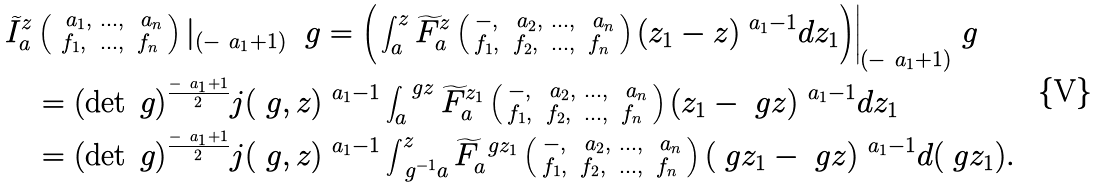Convert formula to latex. <formula><loc_0><loc_0><loc_500><loc_500>\widetilde { I } ^ { z } _ { a } & \left ( \begin{smallmatrix} \ a _ { 1 } , & \dots , & \ a _ { n } \\ f _ { 1 } , & \dots , & f _ { n } \end{smallmatrix} \right ) | _ { ( - \ a _ { 1 } + 1 ) } \ \ g = \Big ( \int _ { a } ^ { z } \widetilde { F } ^ { z } _ { a } \left ( \begin{smallmatrix} - , & \ a _ { 2 } , & \dots , & \ a _ { n } \\ f _ { 1 } , & f _ { 2 } , & \dots , & f _ { n } \end{smallmatrix} \right ) ( z _ { 1 } - z ) ^ { \ a _ { 1 } - 1 } d z _ { 1 } \Big ) \Big | _ { ( - \ a _ { 1 } + 1 ) } \ g \\ & = ( \det \ g ) ^ { \frac { - \ a _ { 1 } + 1 } { 2 } } j ( \ g , z ) ^ { \ a _ { 1 } - 1 } \int _ { a } ^ { \ g z } \widetilde { F } ^ { z _ { 1 } } _ { a } \left ( \begin{smallmatrix} - , & \ a _ { 2 } , & \dots , & \ a _ { n } \\ f _ { 1 } , & f _ { 2 } , & \dots , & f _ { n } \end{smallmatrix} \right ) ( z _ { 1 } - \ g z ) ^ { \ a _ { 1 } - 1 } d z _ { 1 } \\ & = ( \det \ g ) ^ { \frac { - \ a _ { 1 } + 1 } { 2 } } j ( \ g , z ) ^ { \ a _ { 1 } - 1 } \int _ { \ g ^ { - 1 } a } ^ { z } \widetilde { F } ^ { \ g z _ { 1 } } _ { a } \left ( \begin{smallmatrix} - , & \ a _ { 2 } , & \dots , & \ a _ { n } \\ f _ { 1 } , & f _ { 2 } , & \dots , & f _ { n } \end{smallmatrix} \right ) ( \ g z _ { 1 } - \ g z ) ^ { \ a _ { 1 } - 1 } d ( \ g z _ { 1 } ) .</formula> 